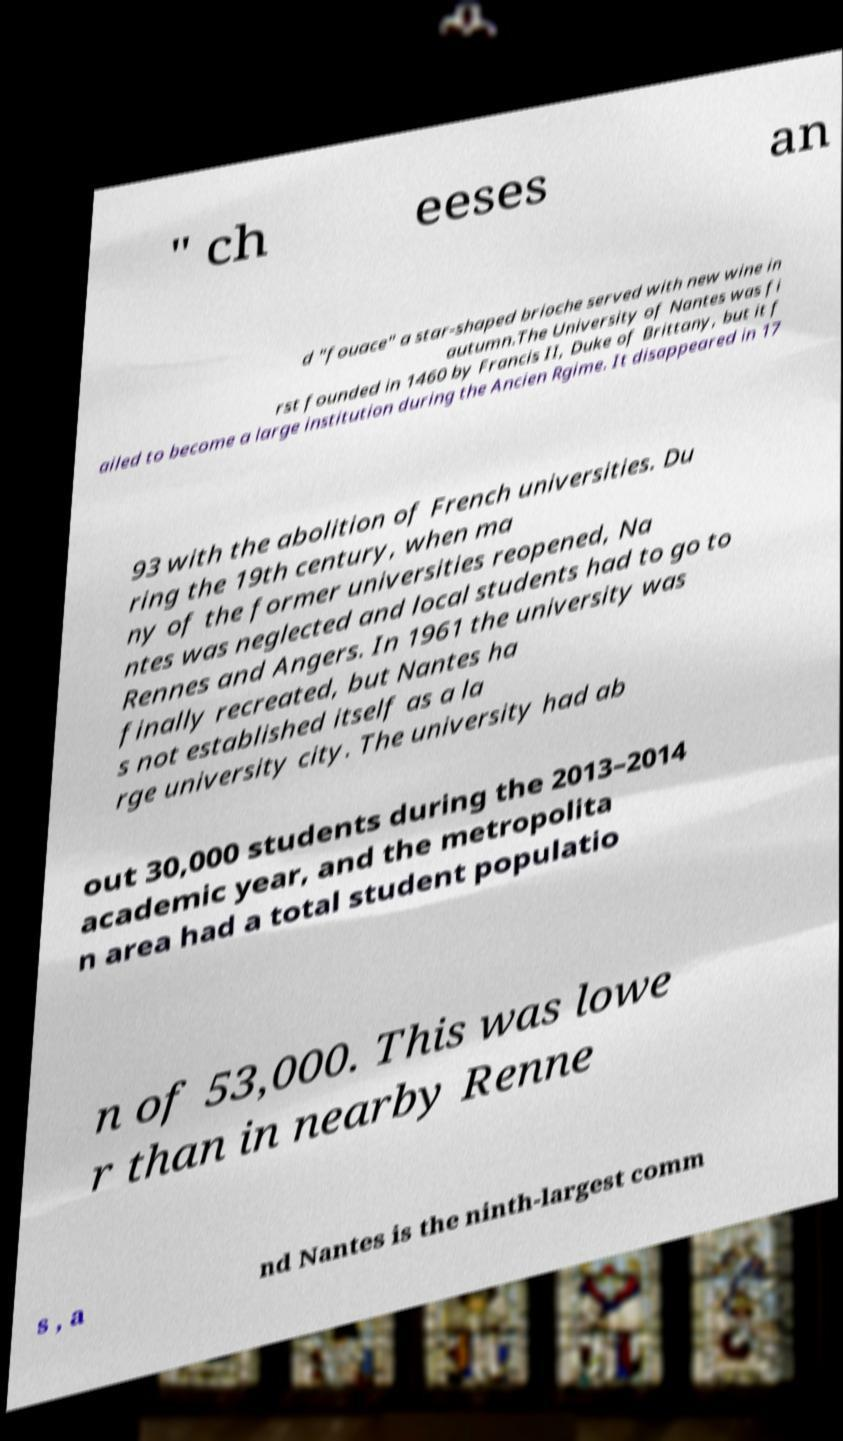Please read and relay the text visible in this image. What does it say? " ch eeses an d "fouace" a star-shaped brioche served with new wine in autumn.The University of Nantes was fi rst founded in 1460 by Francis II, Duke of Brittany, but it f ailed to become a large institution during the Ancien Rgime. It disappeared in 17 93 with the abolition of French universities. Du ring the 19th century, when ma ny of the former universities reopened, Na ntes was neglected and local students had to go to Rennes and Angers. In 1961 the university was finally recreated, but Nantes ha s not established itself as a la rge university city. The university had ab out 30,000 students during the 2013–2014 academic year, and the metropolita n area had a total student populatio n of 53,000. This was lowe r than in nearby Renne s , a nd Nantes is the ninth-largest comm 